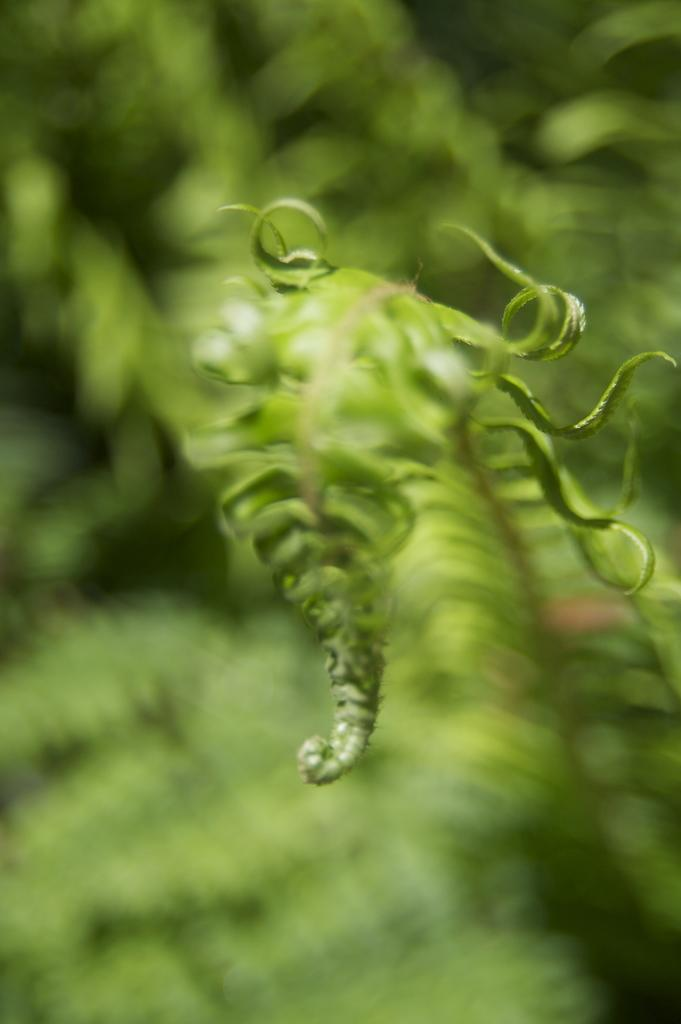What is the main subject of the image? There is a leaf in the center of the image. What can be seen in the background of the image? There is greenery in the background of the image. What type of stamp can be seen on the leaf in the image? There is no stamp present on the leaf in the image. What color is the curtain hanging behind the leaf in the image? There is no curtain present in the image; it only features a leaf and greenery in the background. 